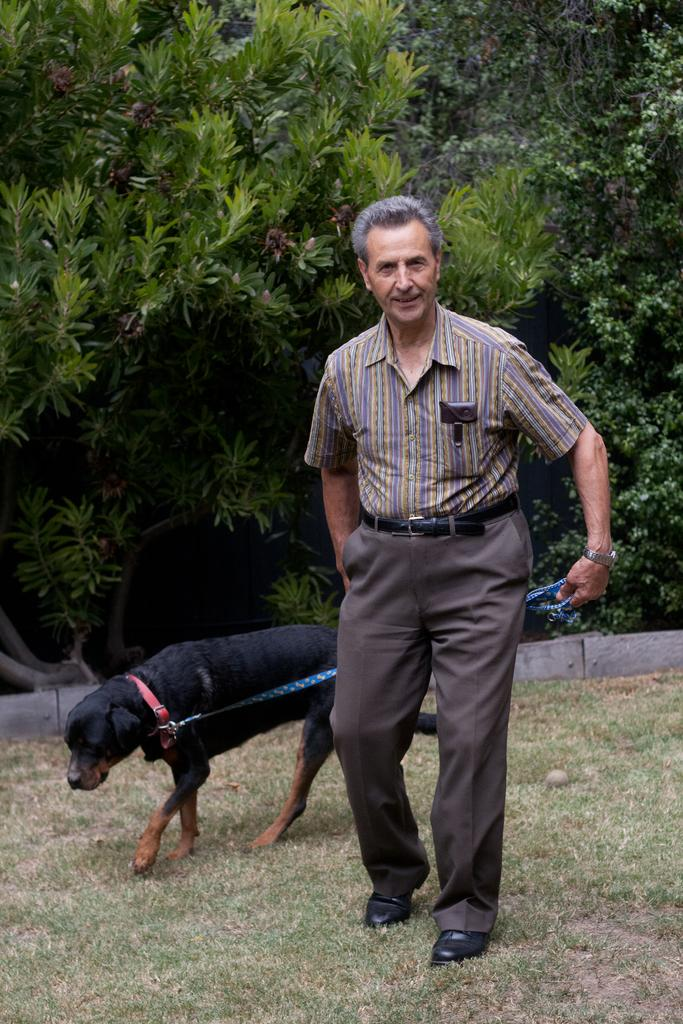What is the main subject of the image? There is a man in the image. What is the man doing in the image? The man is walking in the image. Is there any interaction between the man and an animal in the image? Yes, the man is holding a dog in the image. What can be seen in the background of the image? There are trees, plants, and grass visible in the background of the image. What type of cheese is being used to condition the quiver in the image? There is no cheese, conditioning, or quiver present in the image. 